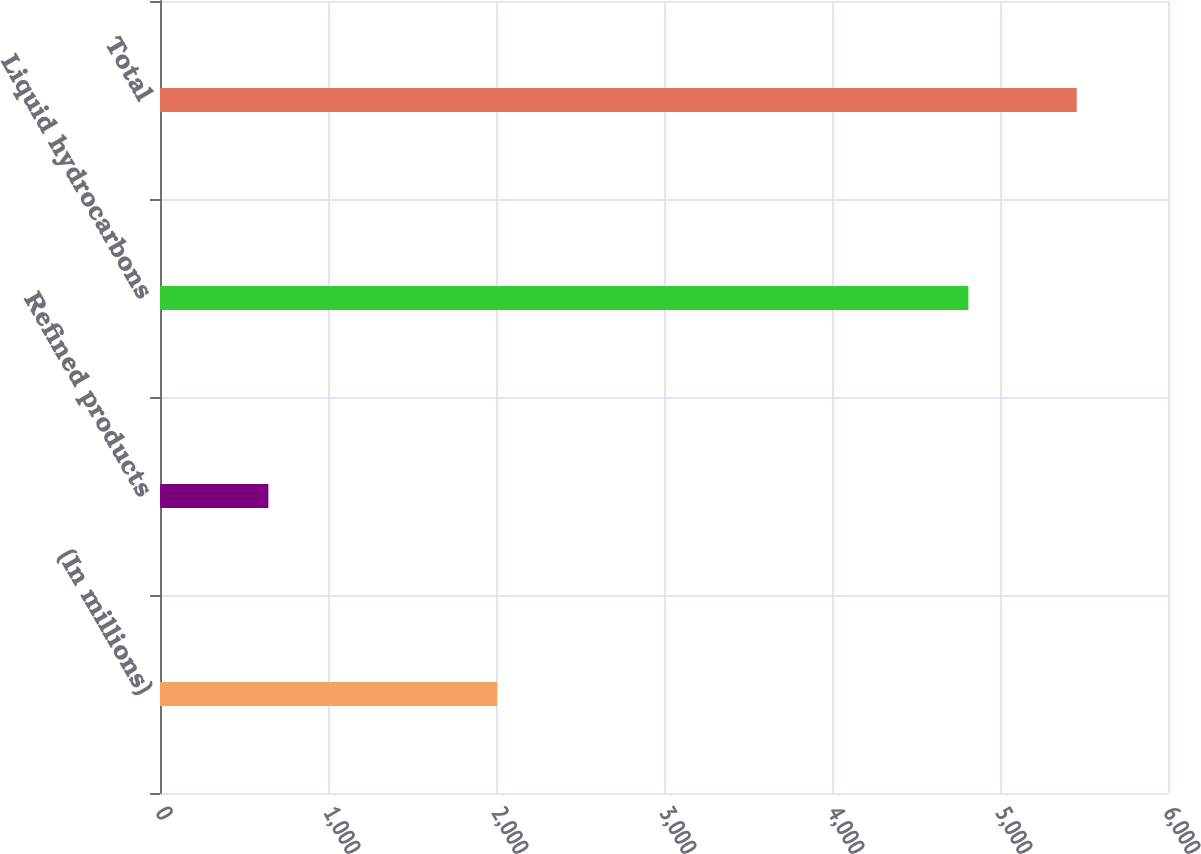Convert chart. <chart><loc_0><loc_0><loc_500><loc_500><bar_chart><fcel>(In millions)<fcel>Refined products<fcel>Liquid hydrocarbons<fcel>Total<nl><fcel>2006<fcel>645<fcel>4812<fcel>5457<nl></chart> 